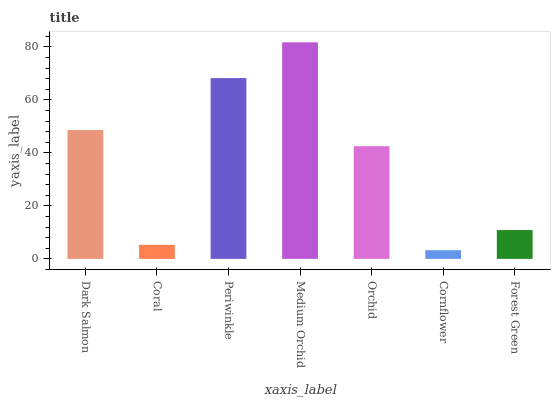Is Cornflower the minimum?
Answer yes or no. Yes. Is Medium Orchid the maximum?
Answer yes or no. Yes. Is Coral the minimum?
Answer yes or no. No. Is Coral the maximum?
Answer yes or no. No. Is Dark Salmon greater than Coral?
Answer yes or no. Yes. Is Coral less than Dark Salmon?
Answer yes or no. Yes. Is Coral greater than Dark Salmon?
Answer yes or no. No. Is Dark Salmon less than Coral?
Answer yes or no. No. Is Orchid the high median?
Answer yes or no. Yes. Is Orchid the low median?
Answer yes or no. Yes. Is Dark Salmon the high median?
Answer yes or no. No. Is Medium Orchid the low median?
Answer yes or no. No. 